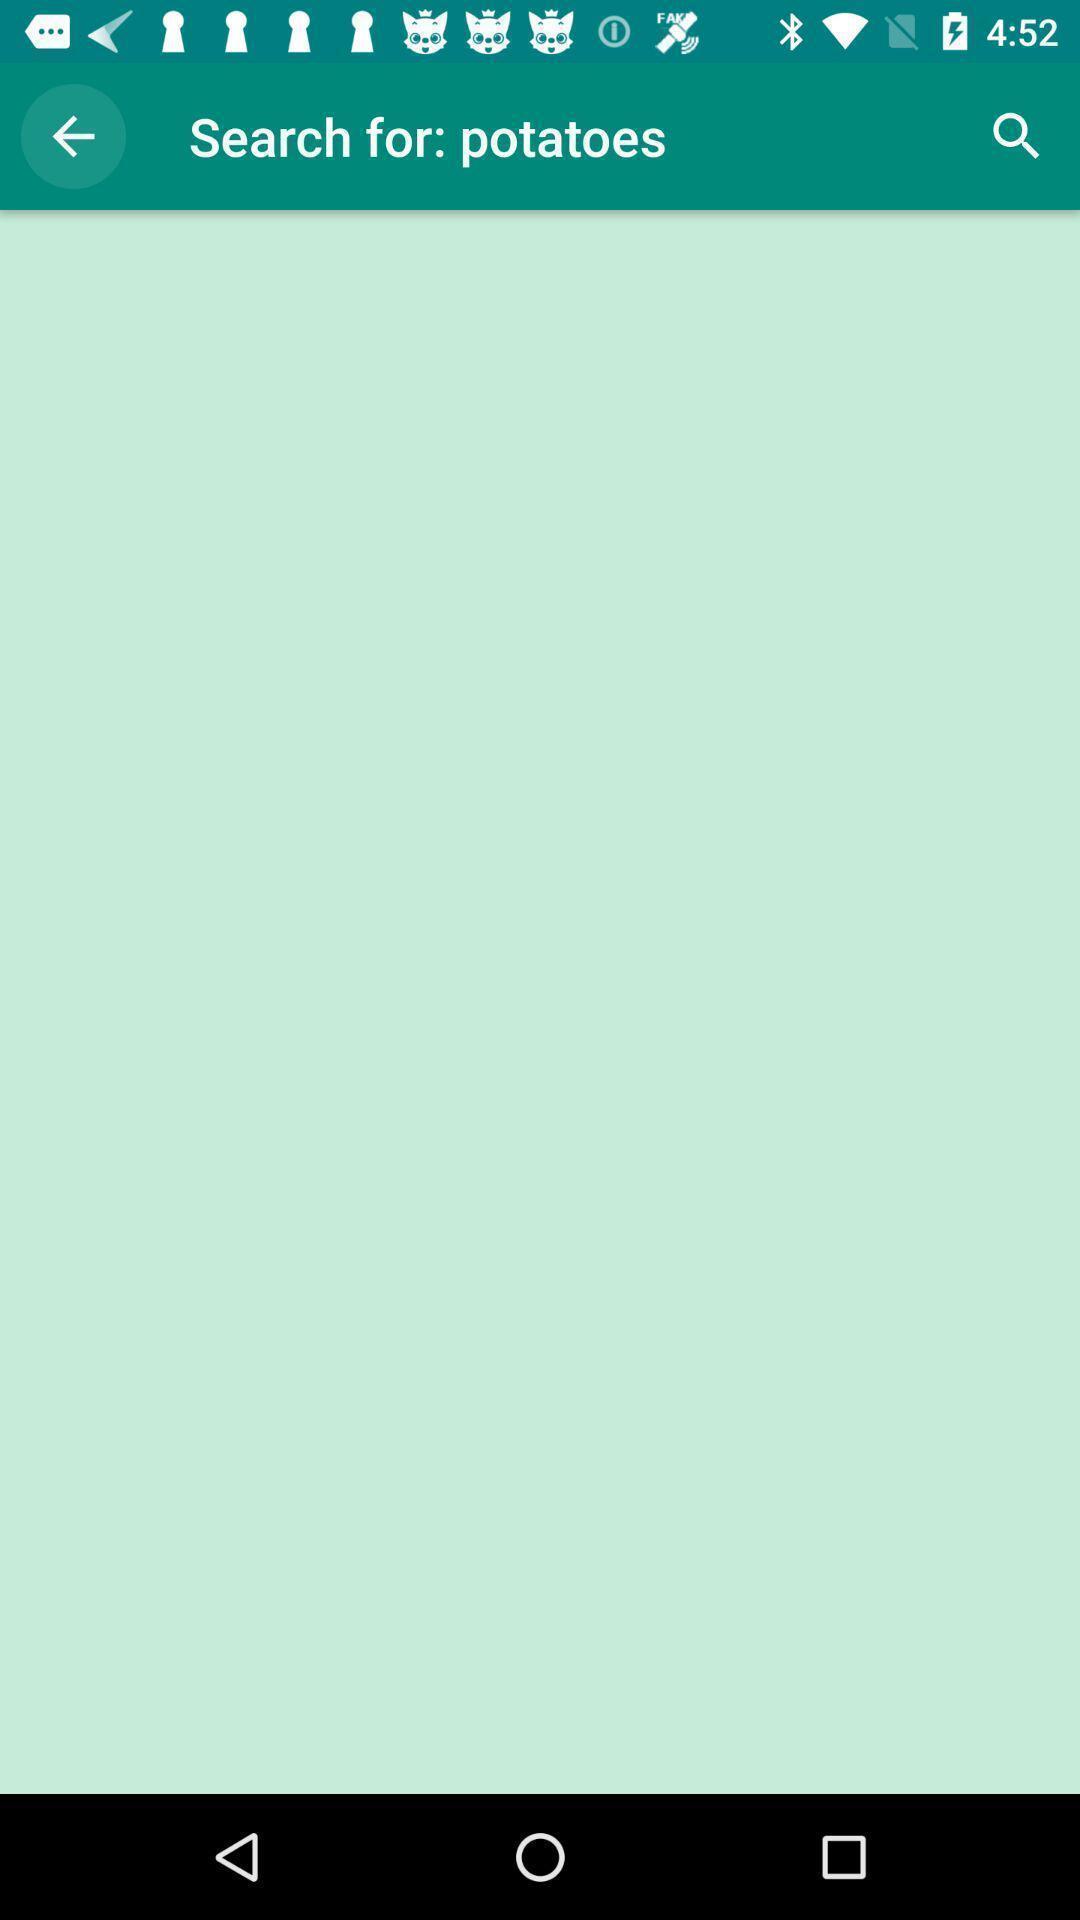Describe the key features of this screenshot. Search page showing for potatoes on an app. 